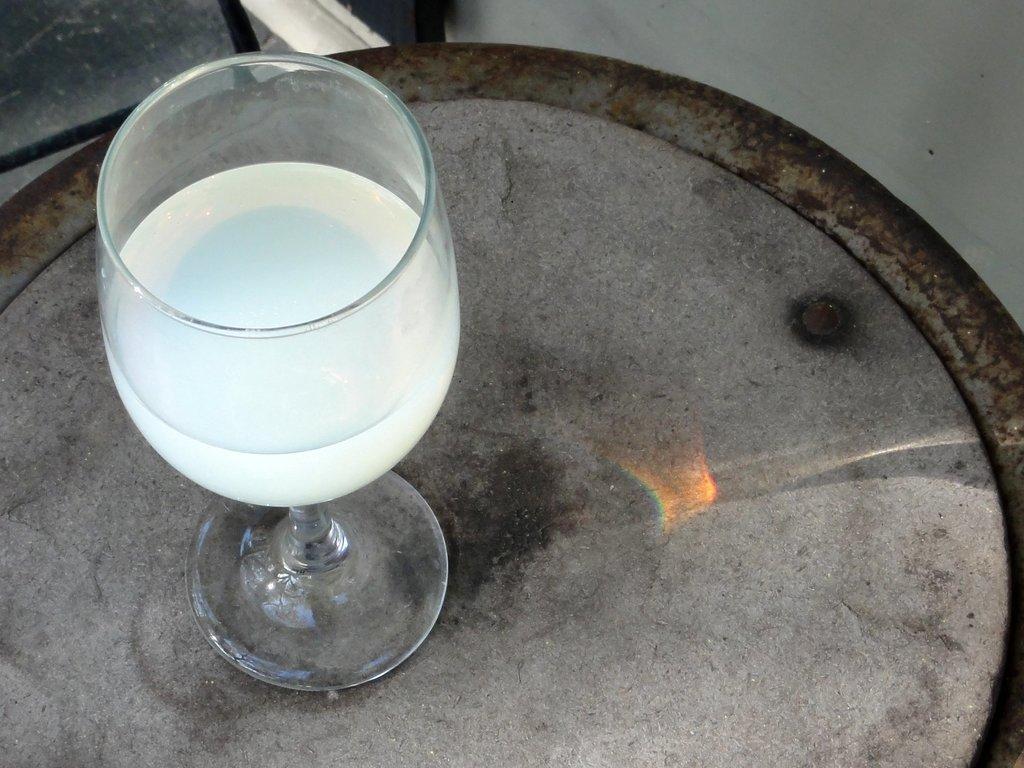Could you give a brief overview of what you see in this image? In this image there is a beverage in tumbler placed on the table. 